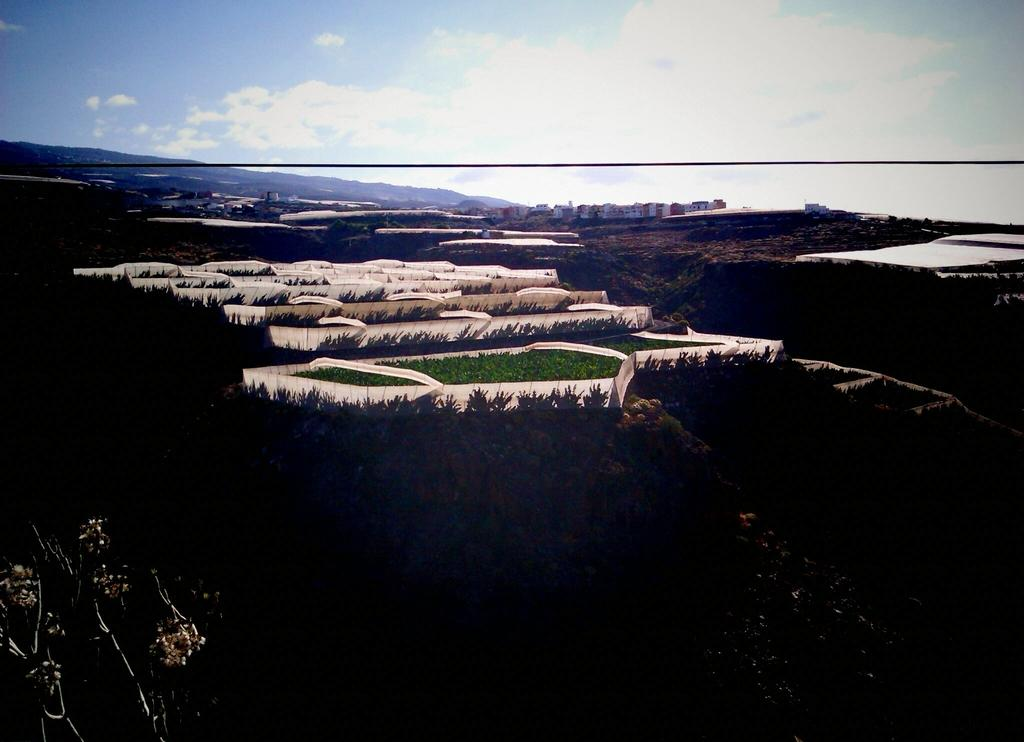What type of landscape is depicted in the image? The image features fields and trees. What can be seen in the background of the image? There are buildings, hills, and the sky visible in the background of the image. How many bears are sleeping under the sheet in the image? There are no bears or sheets present in the image. 